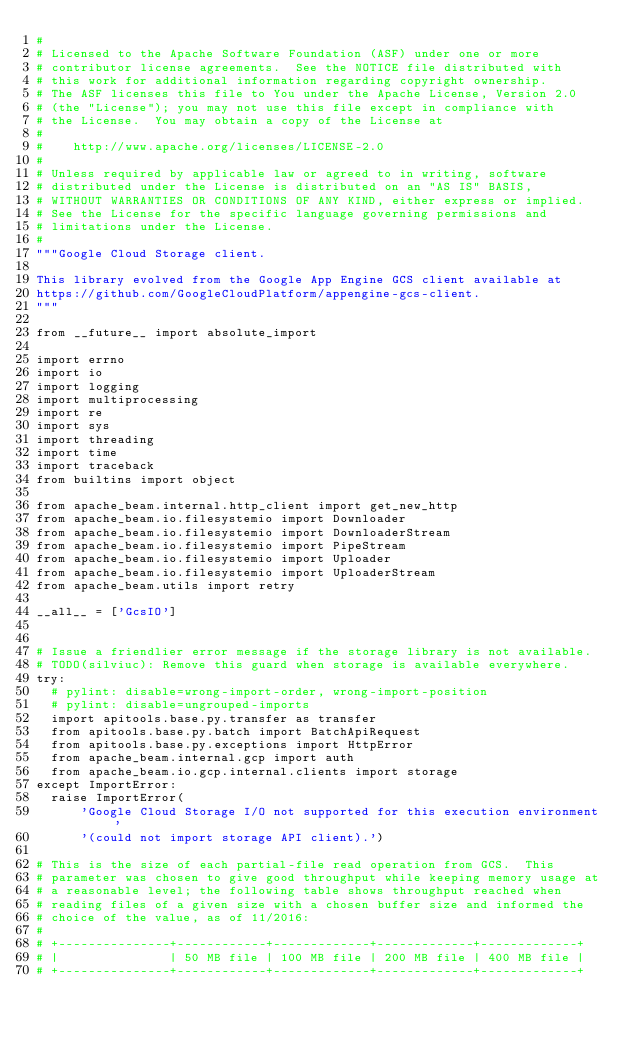Convert code to text. <code><loc_0><loc_0><loc_500><loc_500><_Python_>#
# Licensed to the Apache Software Foundation (ASF) under one or more
# contributor license agreements.  See the NOTICE file distributed with
# this work for additional information regarding copyright ownership.
# The ASF licenses this file to You under the Apache License, Version 2.0
# (the "License"); you may not use this file except in compliance with
# the License.  You may obtain a copy of the License at
#
#    http://www.apache.org/licenses/LICENSE-2.0
#
# Unless required by applicable law or agreed to in writing, software
# distributed under the License is distributed on an "AS IS" BASIS,
# WITHOUT WARRANTIES OR CONDITIONS OF ANY KIND, either express or implied.
# See the License for the specific language governing permissions and
# limitations under the License.
#
"""Google Cloud Storage client.

This library evolved from the Google App Engine GCS client available at
https://github.com/GoogleCloudPlatform/appengine-gcs-client.
"""

from __future__ import absolute_import

import errno
import io
import logging
import multiprocessing
import re
import sys
import threading
import time
import traceback
from builtins import object

from apache_beam.internal.http_client import get_new_http
from apache_beam.io.filesystemio import Downloader
from apache_beam.io.filesystemio import DownloaderStream
from apache_beam.io.filesystemio import PipeStream
from apache_beam.io.filesystemio import Uploader
from apache_beam.io.filesystemio import UploaderStream
from apache_beam.utils import retry

__all__ = ['GcsIO']


# Issue a friendlier error message if the storage library is not available.
# TODO(silviuc): Remove this guard when storage is available everywhere.
try:
  # pylint: disable=wrong-import-order, wrong-import-position
  # pylint: disable=ungrouped-imports
  import apitools.base.py.transfer as transfer
  from apitools.base.py.batch import BatchApiRequest
  from apitools.base.py.exceptions import HttpError
  from apache_beam.internal.gcp import auth
  from apache_beam.io.gcp.internal.clients import storage
except ImportError:
  raise ImportError(
      'Google Cloud Storage I/O not supported for this execution environment '
      '(could not import storage API client).')

# This is the size of each partial-file read operation from GCS.  This
# parameter was chosen to give good throughput while keeping memory usage at
# a reasonable level; the following table shows throughput reached when
# reading files of a given size with a chosen buffer size and informed the
# choice of the value, as of 11/2016:
#
# +---------------+------------+-------------+-------------+-------------+
# |               | 50 MB file | 100 MB file | 200 MB file | 400 MB file |
# +---------------+------------+-------------+-------------+-------------+</code> 